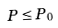Convert formula to latex. <formula><loc_0><loc_0><loc_500><loc_500>P \leq P _ { 0 }</formula> 